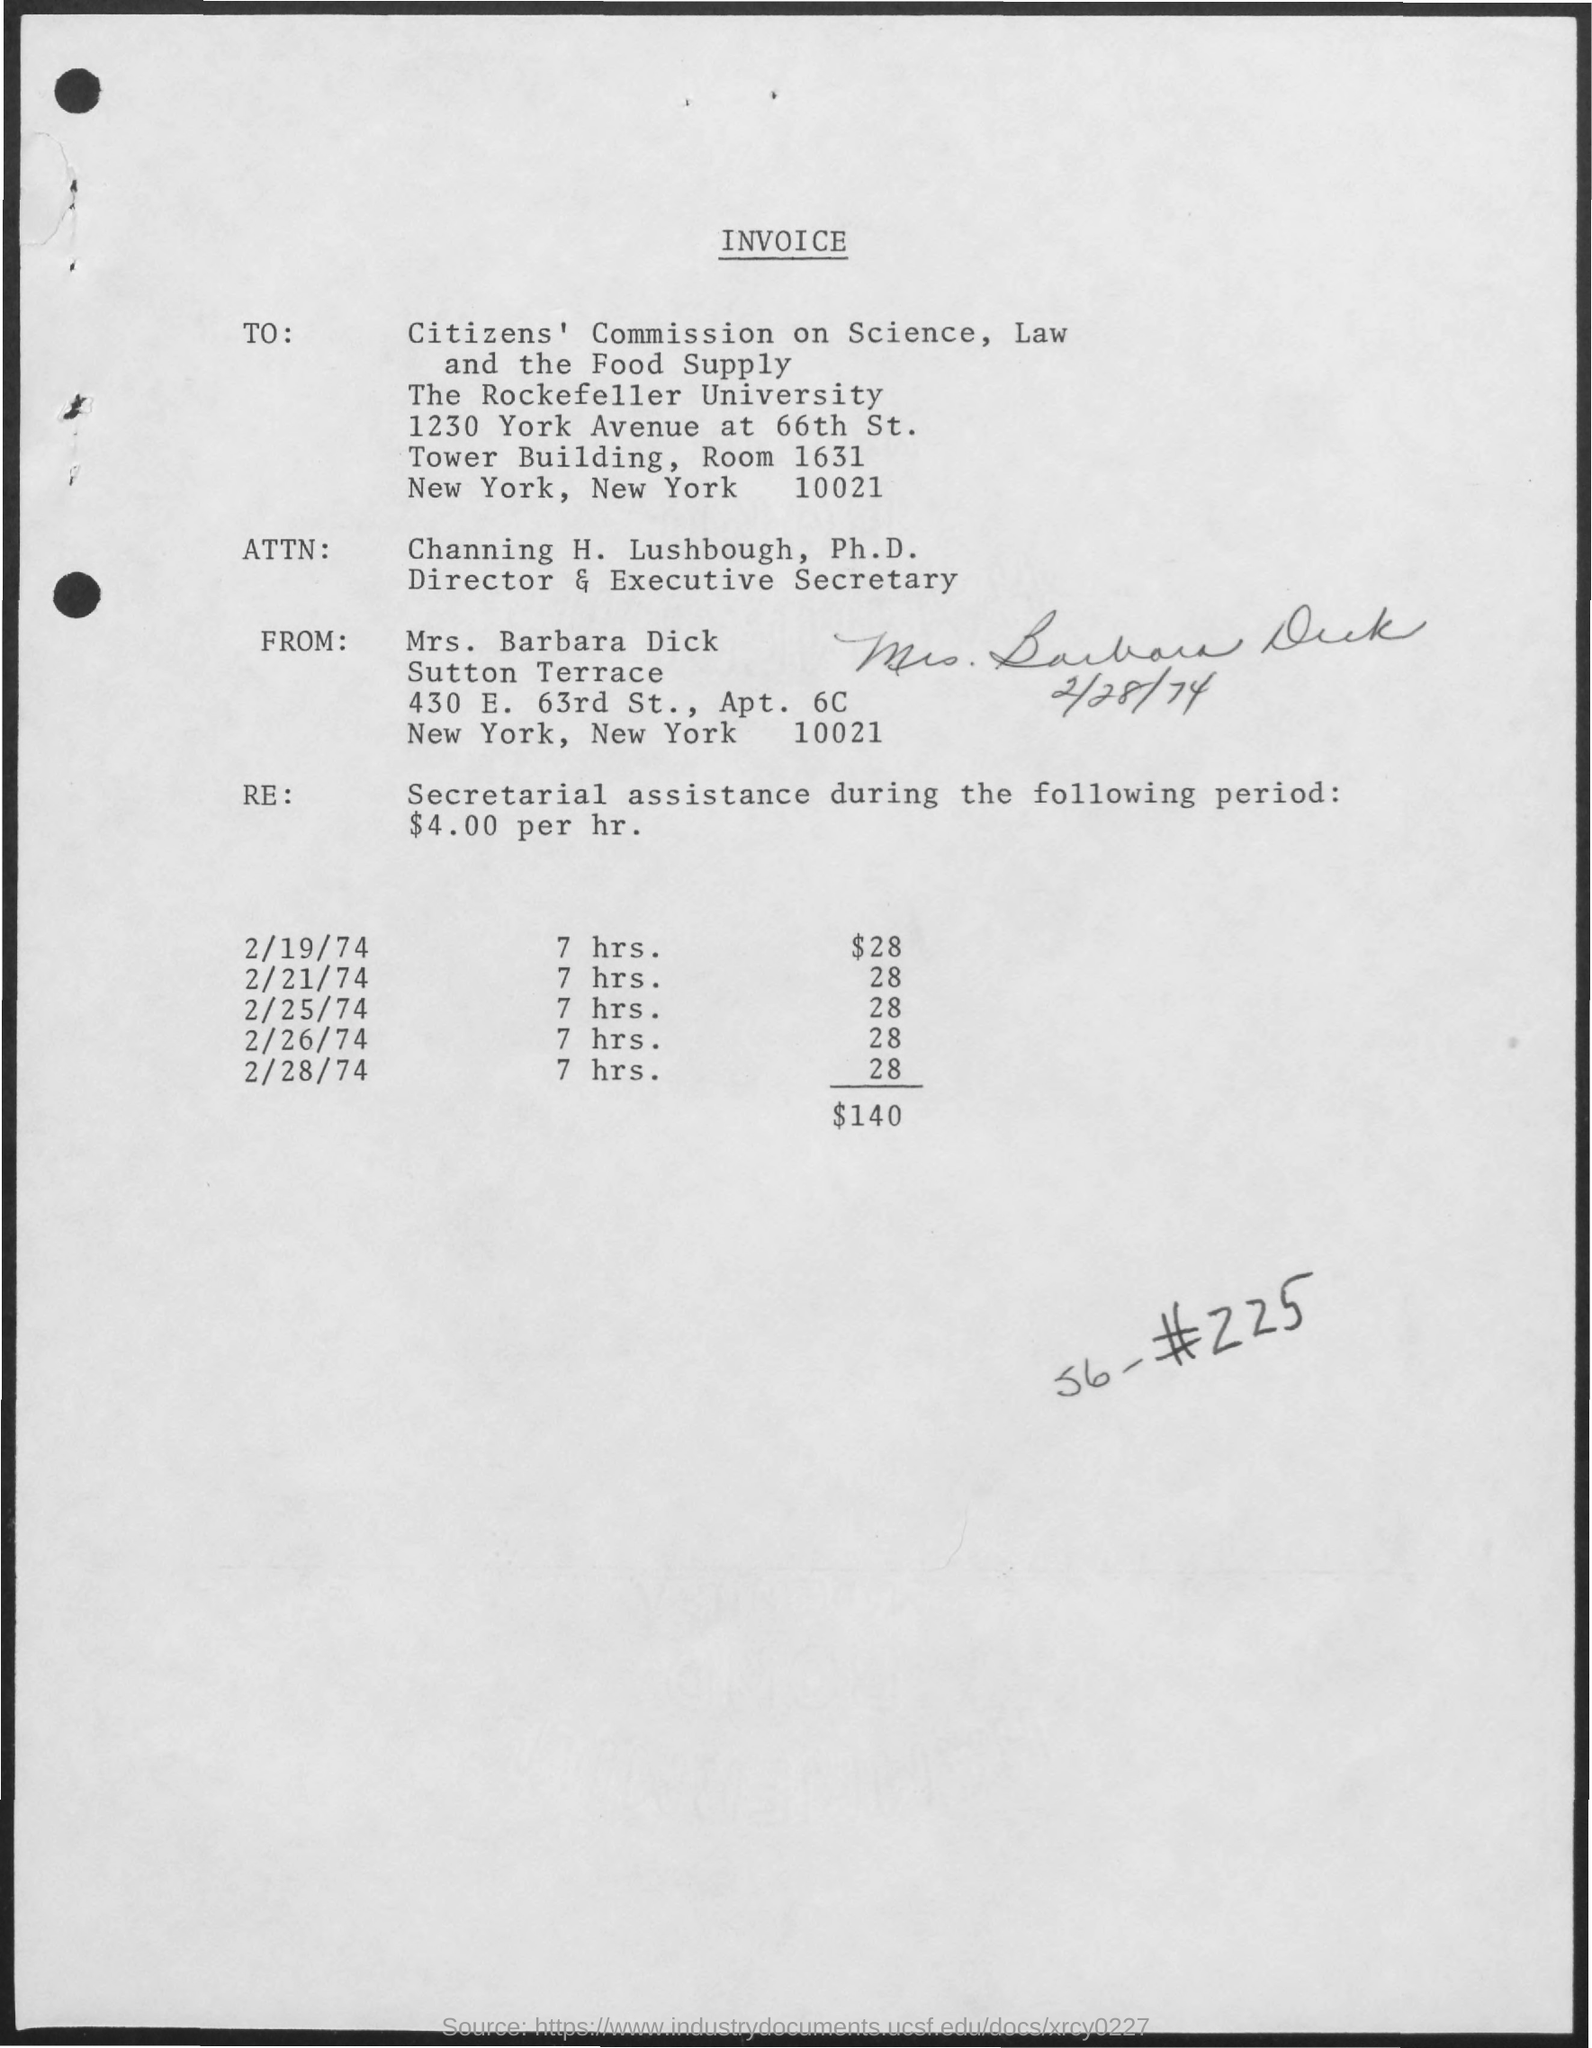Mention a couple of crucial points in this snapshot. On February 19th, 1974, a given amount was provided for 7 hours. Channing H. Lushbough's designation is that of Director and Executive Secretary. The invoice is delivered to Mrs. Barbara Dick. 